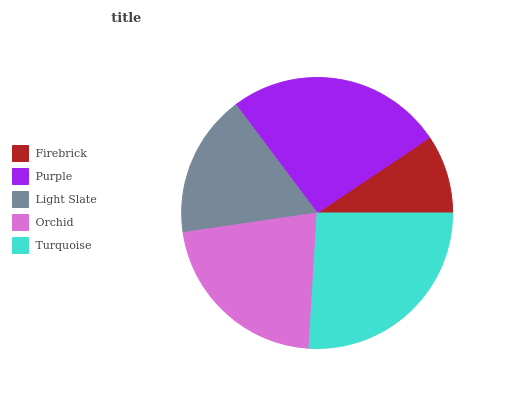Is Firebrick the minimum?
Answer yes or no. Yes. Is Turquoise the maximum?
Answer yes or no. Yes. Is Purple the minimum?
Answer yes or no. No. Is Purple the maximum?
Answer yes or no. No. Is Purple greater than Firebrick?
Answer yes or no. Yes. Is Firebrick less than Purple?
Answer yes or no. Yes. Is Firebrick greater than Purple?
Answer yes or no. No. Is Purple less than Firebrick?
Answer yes or no. No. Is Orchid the high median?
Answer yes or no. Yes. Is Orchid the low median?
Answer yes or no. Yes. Is Turquoise the high median?
Answer yes or no. No. Is Firebrick the low median?
Answer yes or no. No. 